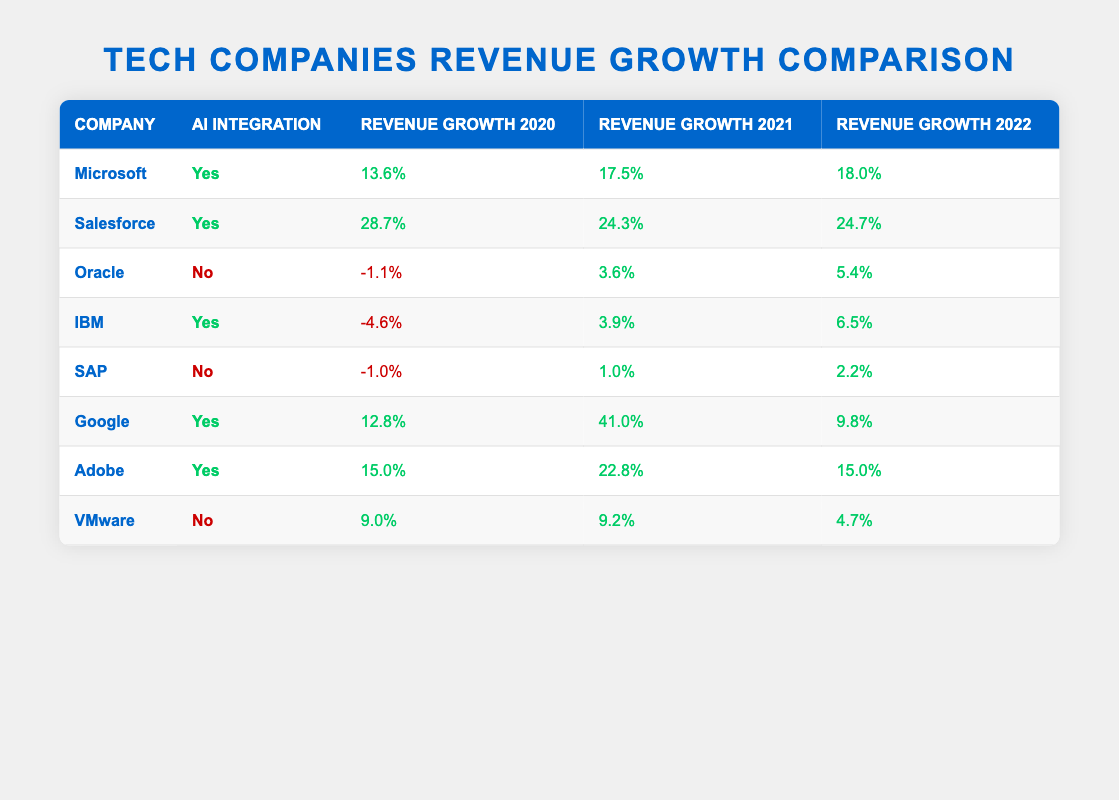What is the revenue growth percentage of Microsoft in 2021? The table indicates that Microsoft's revenue growth for the year 2021 is listed as 17.5%.
Answer: 17.5% Which company experienced a negative revenue growth in 2020? According to the table, both IBM (-4.6%) and Oracle (-1.1%) showed negative revenue growth for the year 2020.
Answer: IBM and Oracle What was the highest revenue growth percentage in 2021 among the companies listed? By examining the revenue growth for 2021, Salesforce had the highest percentage at 24.3%.
Answer: 24.3% What is the average revenue growth for Google across the three years listed? To calculate the average, sum the three growth percentages for Google: (12.8% + 41.0% + 9.8%) = 63.6%. Then divide by 3, getting an average of 21.2%.
Answer: 21.2% Did VMware have positive revenue growth in all three years? Checking the table reveals that VMware had revenue growth percentages of 9.0%, 9.2%, and 4.7%, which are all positive figures.
Answer: Yes Which company had revenue growth improvement from 2020 to 2022? Examining the data shows that Microsoft consistently improved from 13.6% in 2020 to 18.0% in 2022, indicating that it had revenue growth improvement over these years.
Answer: Microsoft How many companies without AI integration had a positive revenue growth in 2021? From the table, Oracle and SAP are the only companies without AI integration, and they recorded a revenue growth of 3.6% and 1.0%, respectively, which are both positive.
Answer: 2 What is the difference in revenue growth between Salesforce in 2020 and Oracle in 2022? Salesforce had a revenue growth of 28.7% in 2020, while Oracle had a revenue growth of 5.4% in 2022. The difference is 28.7% - 5.4% = 23.3%.
Answer: 23.3% Is it true that all companies with AI integration had positive revenue growth in 2021? Looking at the table, it's clear that IBM had a positive growth of 3.9% in 2021, yet it had negative growth in 2020. Therefore, the statement that all companies with AI integration had positive growth in 2021 is misleading.
Answer: No 